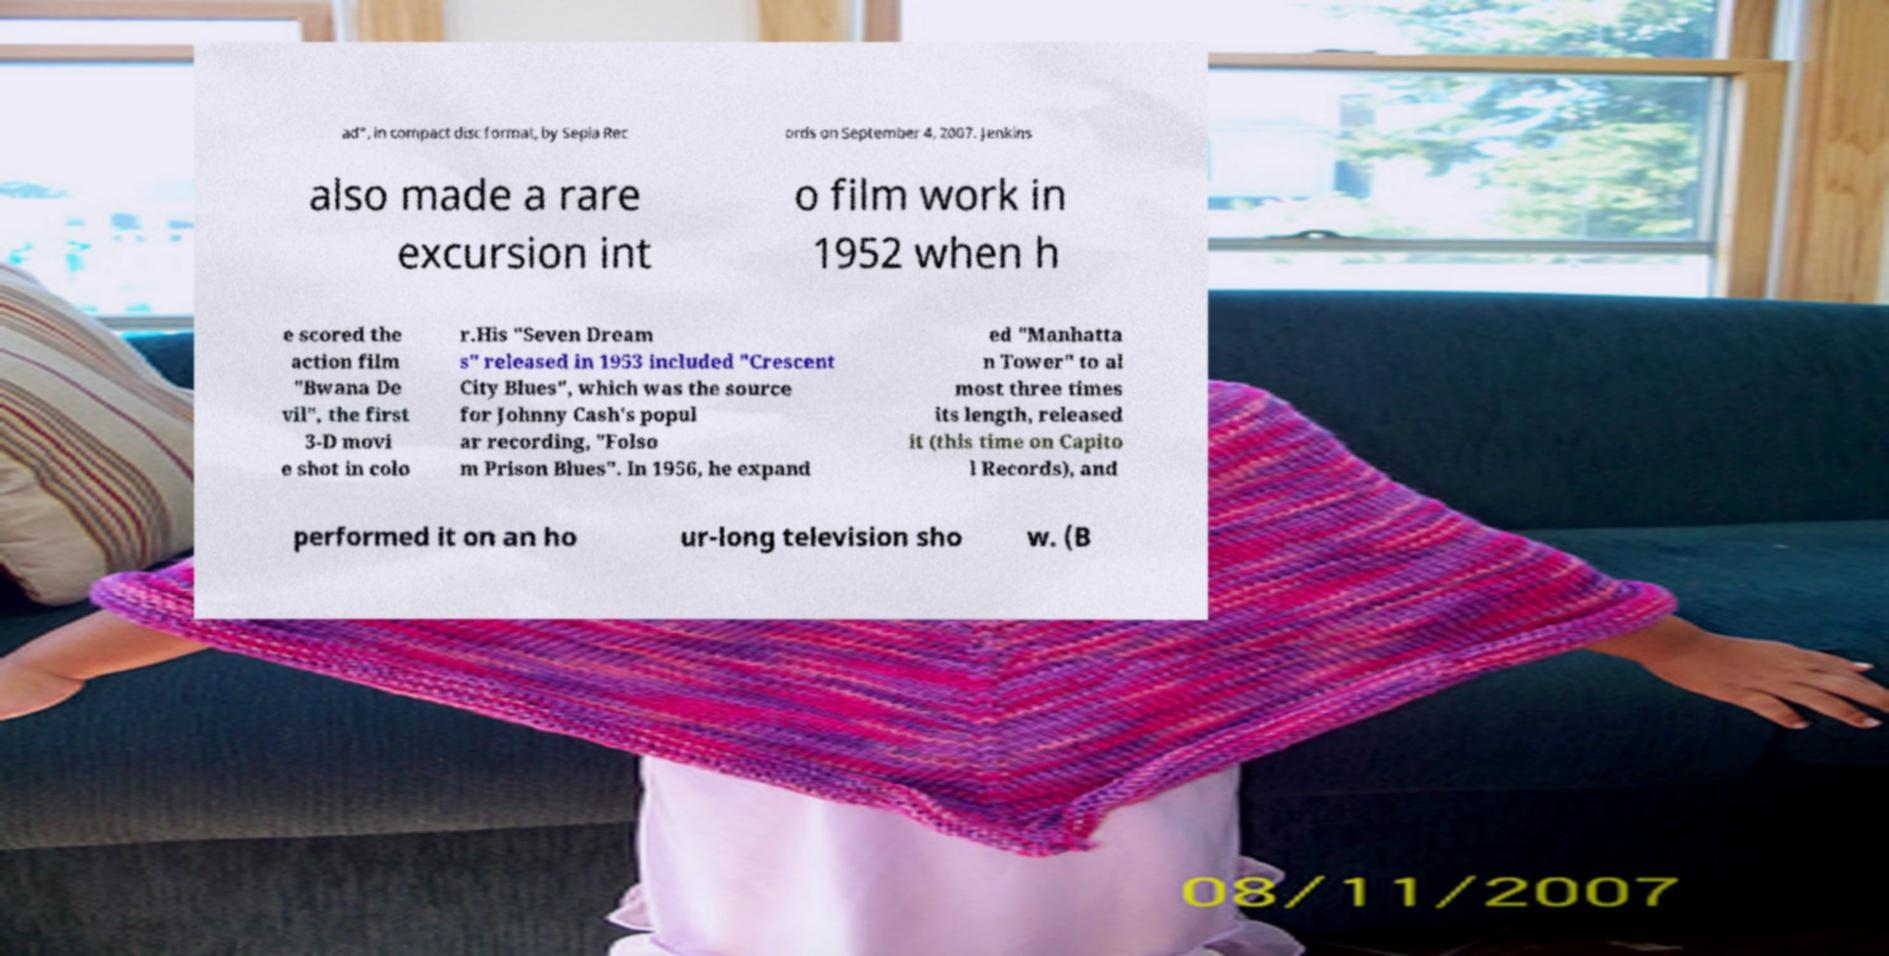Can you accurately transcribe the text from the provided image for me? ad", in compact disc format, by Sepia Rec ords on September 4, 2007. Jenkins also made a rare excursion int o film work in 1952 when h e scored the action film "Bwana De vil", the first 3-D movi e shot in colo r.His "Seven Dream s" released in 1953 included "Crescent City Blues", which was the source for Johnny Cash's popul ar recording, "Folso m Prison Blues". In 1956, he expand ed "Manhatta n Tower" to al most three times its length, released it (this time on Capito l Records), and performed it on an ho ur-long television sho w. (B 